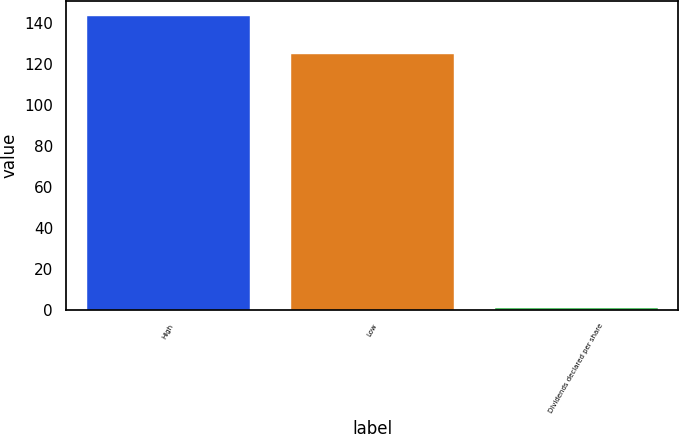Convert chart to OTSL. <chart><loc_0><loc_0><loc_500><loc_500><bar_chart><fcel>High<fcel>Low<fcel>Dividends declared per share<nl><fcel>143.43<fcel>124.77<fcel>0.64<nl></chart> 